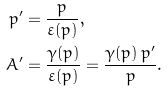<formula> <loc_0><loc_0><loc_500><loc_500>p ^ { \prime } & = \frac { p } { \varepsilon ( p ) } , \\ A ^ { \prime } & = \frac { \gamma ( p ) } { \varepsilon ( p ) } = \frac { \gamma ( p ) \, p ^ { \prime } } { p } .</formula> 